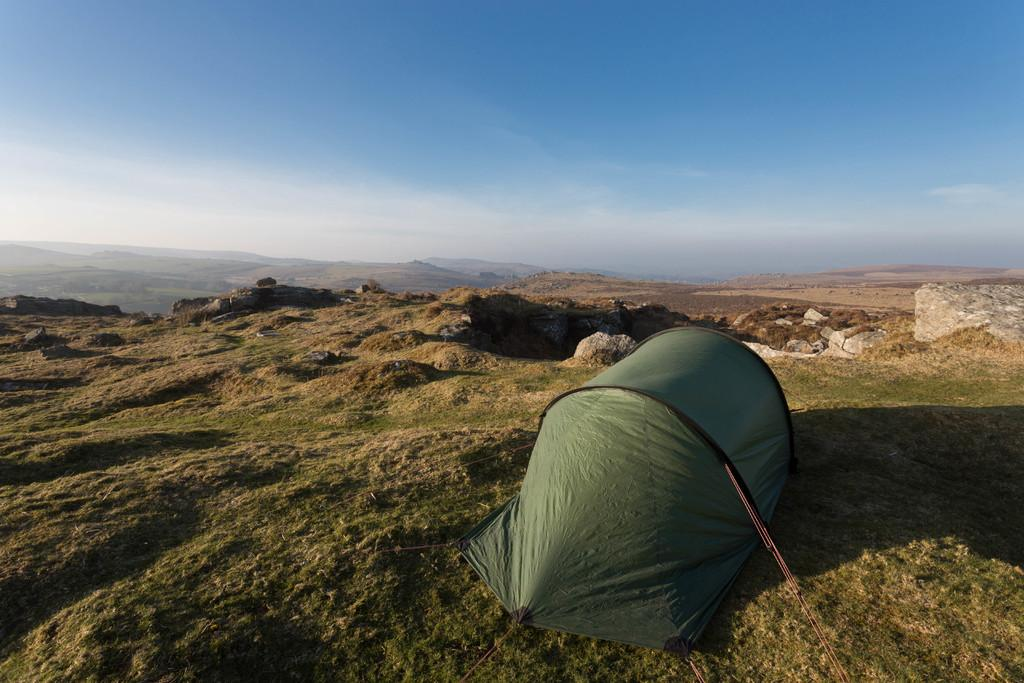What structure is present in the image? There is a tent in the image. What feature can be seen on the tent? The tent has ropes. Where is the tent located? The tent is on the grass. What can be seen in the background of the image? There are mountains, rocks, and the sky visible in the background of the image. What type of owl can be seen perched on the tent in the image? There is no owl present in the image; it only features a tent, ropes, grass, mountains, rocks, and the sky. 